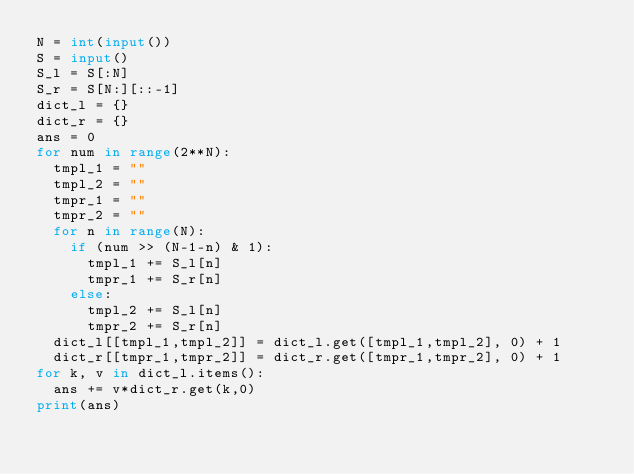<code> <loc_0><loc_0><loc_500><loc_500><_Python_>N = int(input())
S = input()
S_l = S[:N]
S_r = S[N:][::-1]
dict_l = {}
dict_r = {}
ans = 0
for num in range(2**N):
  tmpl_1 = ""
  tmpl_2 = ""
  tmpr_1 = ""
  tmpr_2 = ""
  for n in range(N):
    if (num >> (N-1-n) & 1):
      tmpl_1 += S_l[n]
      tmpr_1 += S_r[n]
    else:
      tmpl_2 += S_l[n]
      tmpr_2 += S_r[n]
  dict_l[[tmpl_1,tmpl_2]] = dict_l.get([tmpl_1,tmpl_2], 0) + 1
  dict_r[[tmpr_1,tmpr_2]] = dict_r.get([tmpr_1,tmpr_2], 0) + 1
for k, v in dict_l.items():
  ans += v*dict_r.get(k,0)
print(ans)
</code> 